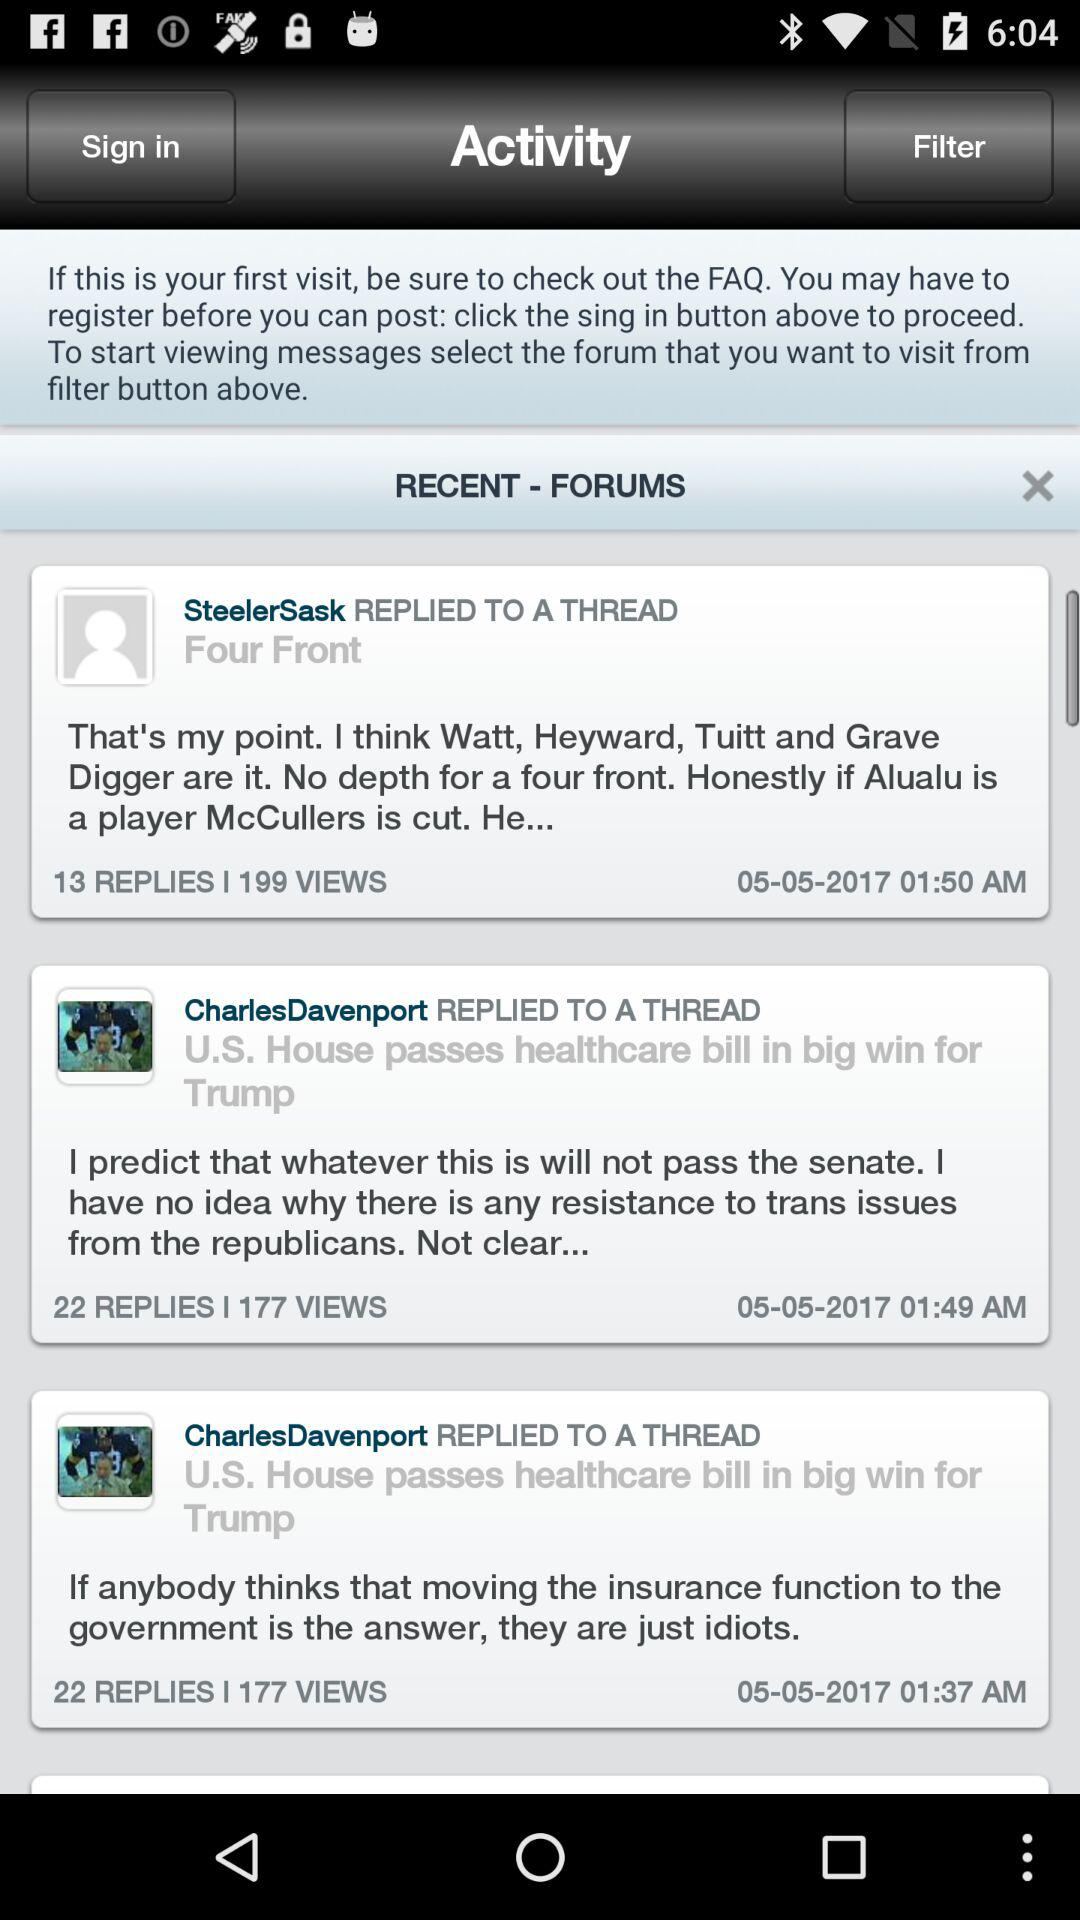How many people replied to Steeler Sask's reply? There were 13 people who replied to Steeler Sask's reply. 